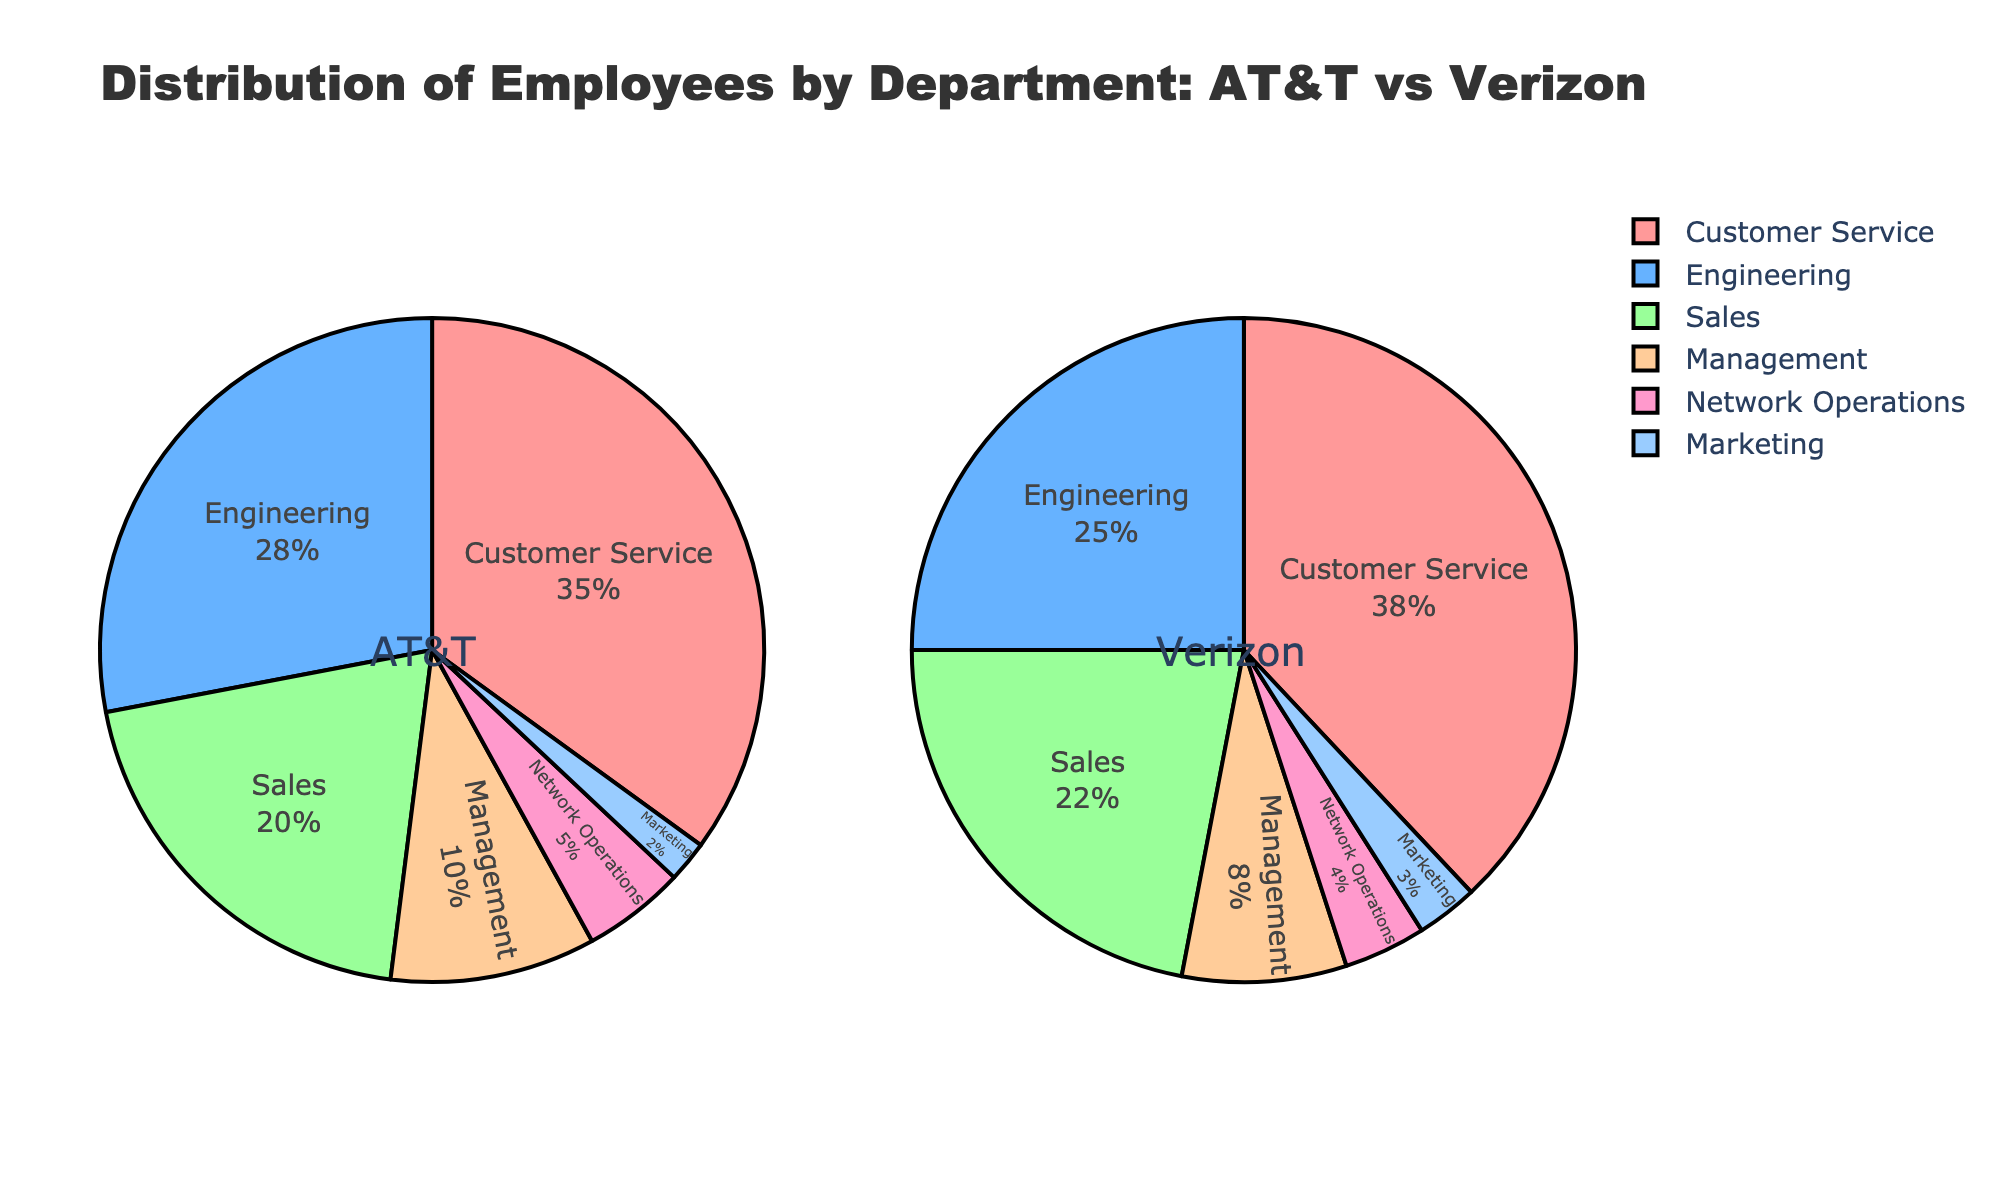How do the proportions of employees in customer service compare between AT&T and Verizon? The pie charts show that AT&T has 35% of its employees in customer service, while Verizon has 38%. By visual inspection, Verizon's segment looks slightly larger.
Answer: Verizon has a higher proportion Which department has the smallest segment in both companies? By looking at the smallest portions in both pie charts, it is evident that the marketing segment is the smallest in both AT&T and Verizon.
Answer: Marketing What is the total percentage of employees working in management and network operations in AT&T? The pie chart for AT&T shows 10% in management and 5% in network operations, summing these percentages gives 10% + 5% = 15%.
Answer: 15% How do the proportions of employees in engineering differ between AT&T and Verizon? AT&T has 28% of its employees in engineering, compared to Verizon's 25%. Thus, AT&T has a slightly larger proportion.
Answer: AT&T has a larger proportion Compare the sum of proportions in marketing and sales between AT&T and Verizon. Which company has a higher percentage? For AT&T, the sum is 2% (marketing) + 20% (sales) = 22%. For Verizon, it is 3% (marketing) + 22% (sales) = 25%. So, Verizon has a higher combined percentage.
Answer: Verizon Which company has a higher percentage of employees in network operations? By examining the pie charts, AT&T has 5% in network operations while Verizon has 4%. Therefore, AT&T has a higher percentage.
Answer: AT&T How does the size of the management segment compare between AT&T and Verizon? The pie charts indicate that the management proportion in AT&T is 10%, while in Verizon, it is 8%. Thus, AT&T has a slightly larger management segment.
Answer: AT&T has a larger segment What is the percentage difference in employees working in sales between AT&T and Verizon? AT&T has 20% of its employees in sales, and Verizon has 22%. The difference is 22% - 20% = 2%.
Answer: 2% If network operations and marketing departments were combined, which company would have the larger segment? For AT&T, the combined percentage is 5% (network operations) + 2% (marketing) = 7%. For Verizon, it is 4% (network operations) + 3% (marketing) = 7%. Both companies have the same combined percentage.
Answer: Both are equal What is the visual indicator that tells you which segments have the highest proportions for both companies? The largest segments within both pie charts for customer service indicate the highest proportions, colored similarly and occupies the most space visually.
Answer: Customer Service 